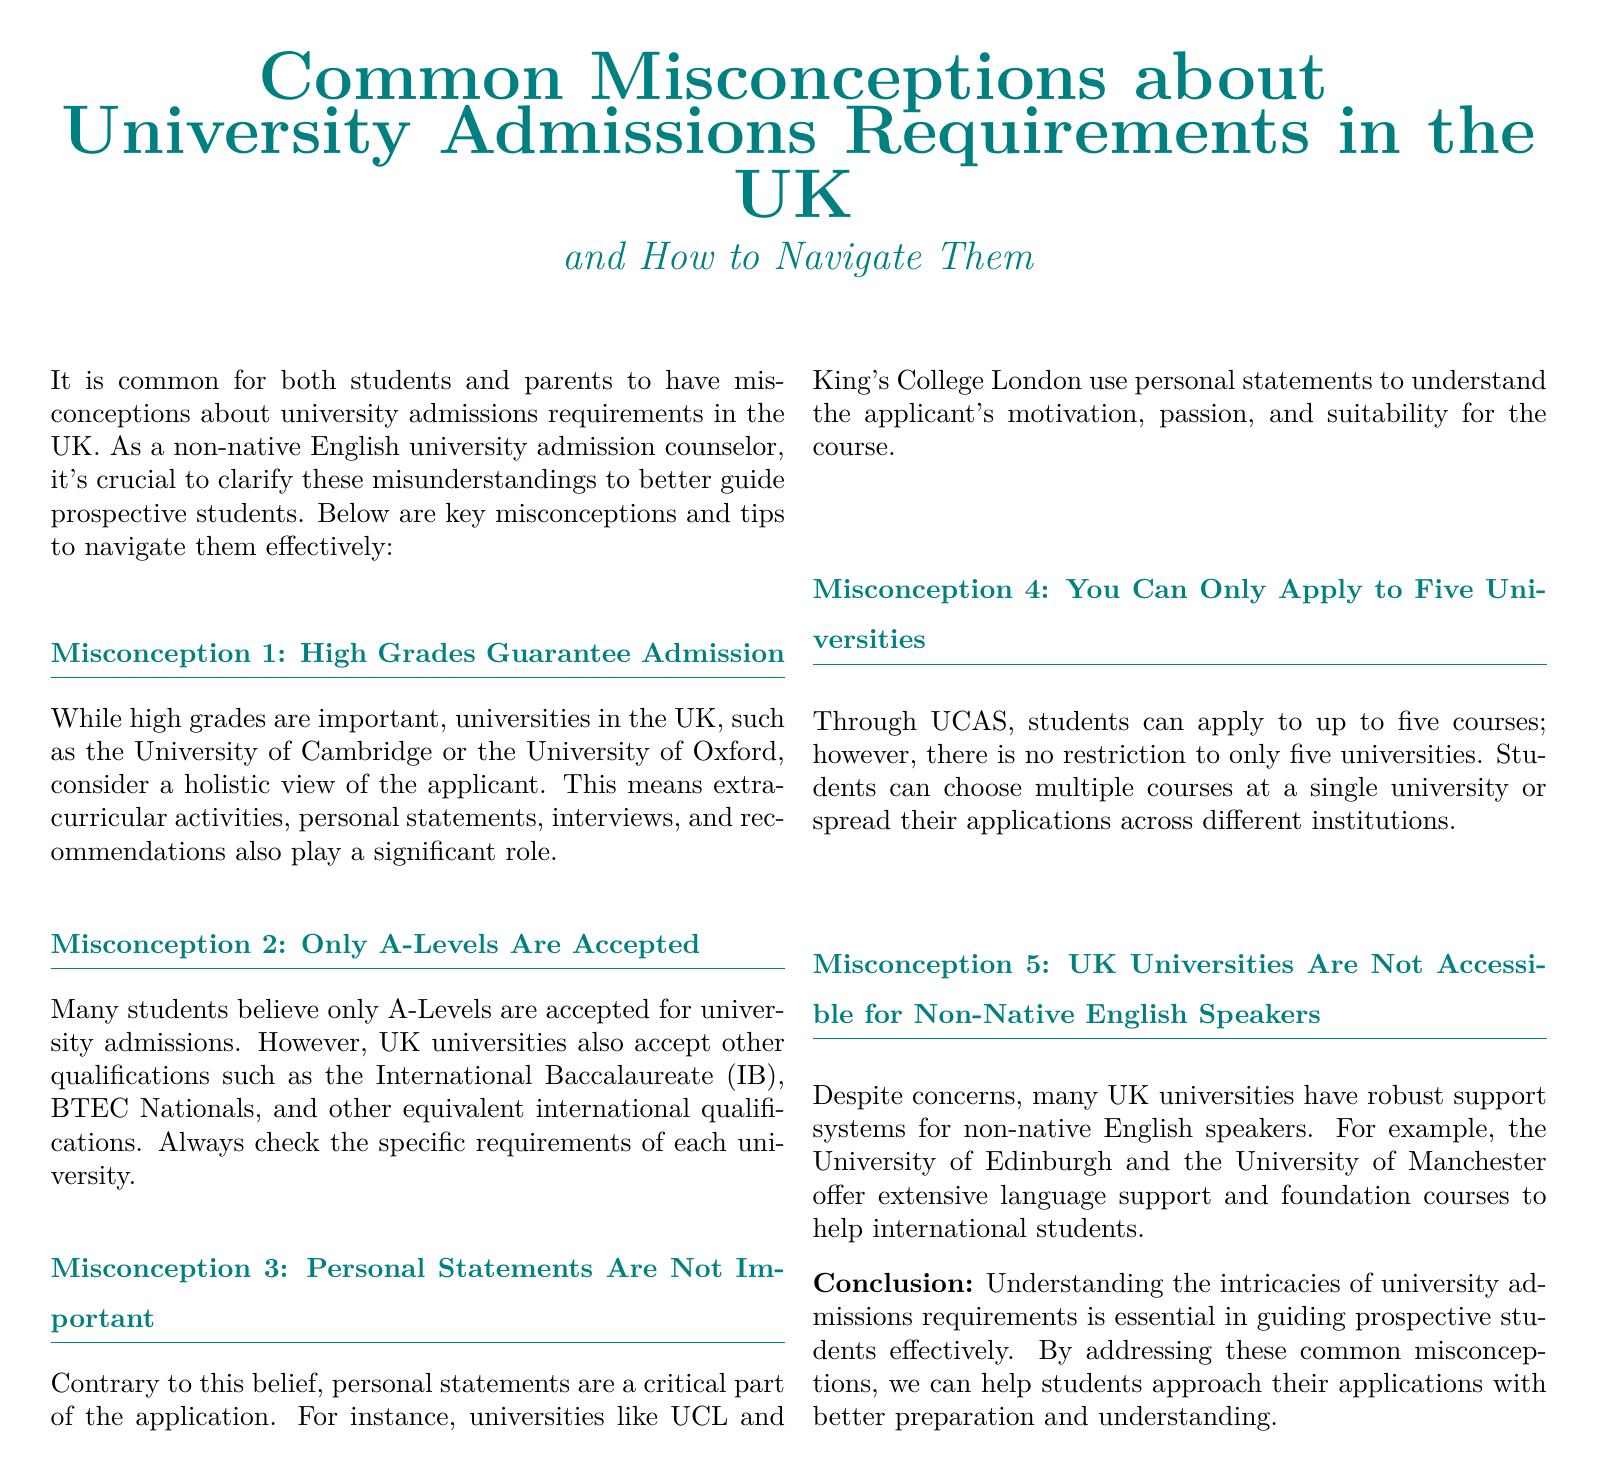What is Myth 1 about university admissions? Myth 1 states that high grades guarantee admission to universities in the UK.
Answer: High Grades Guarantee Admission What additional qualifications are accepted besides A-Levels? The document states that UK universities accept qualifications such as the International Baccalaureate (IB) and BTEC Nationals.
Answer: International Baccalaureate (IB), BTEC Nationals What role do personal statements play in applications? Personal statements are used by universities to understand the applicant's motivation, passion, and suitability for the course.
Answer: Critical part of the application How many courses can students apply to through UCAS? The document mentions that students can apply to up to five courses through UCAS.
Answer: Five courses Are UK universities inaccessible for non-native English speakers? The document indicates that many UK universities have robust support systems for non-native English speakers.
Answer: Not inaccessible What is an example of a university offering language support? The document lists the University of Edinburgh as one of the universities providing extensive language support.
Answer: University of Edinburgh 